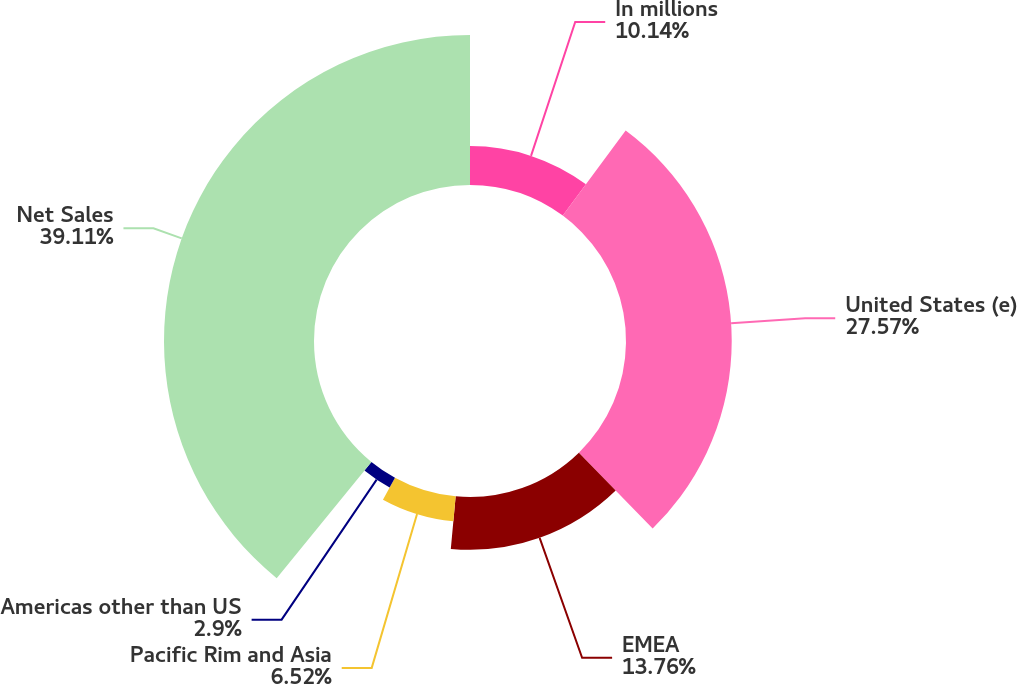<chart> <loc_0><loc_0><loc_500><loc_500><pie_chart><fcel>In millions<fcel>United States (e)<fcel>EMEA<fcel>Pacific Rim and Asia<fcel>Americas other than US<fcel>Net Sales<nl><fcel>10.14%<fcel>27.57%<fcel>13.76%<fcel>6.52%<fcel>2.9%<fcel>39.12%<nl></chart> 